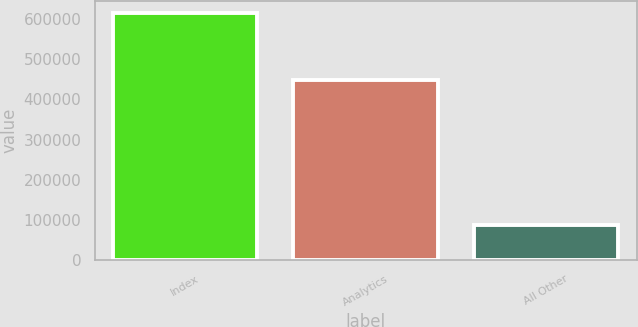<chart> <loc_0><loc_0><loc_500><loc_500><bar_chart><fcel>Index<fcel>Analytics<fcel>All Other<nl><fcel>613551<fcel>448353<fcel>88765<nl></chart> 